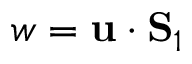Convert formula to latex. <formula><loc_0><loc_0><loc_500><loc_500>w = { u } \cdot { S } _ { 1 }</formula> 